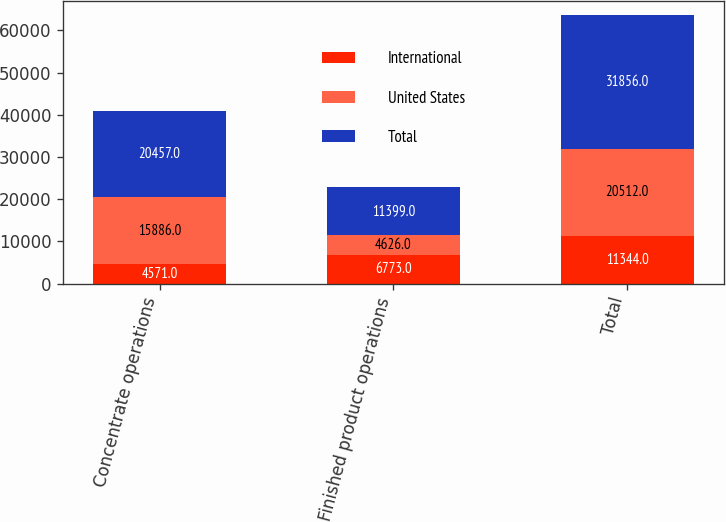<chart> <loc_0><loc_0><loc_500><loc_500><stacked_bar_chart><ecel><fcel>Concentrate operations<fcel>Finished product operations<fcel>Total<nl><fcel>International<fcel>4571<fcel>6773<fcel>11344<nl><fcel>United States<fcel>15886<fcel>4626<fcel>20512<nl><fcel>Total<fcel>20457<fcel>11399<fcel>31856<nl></chart> 